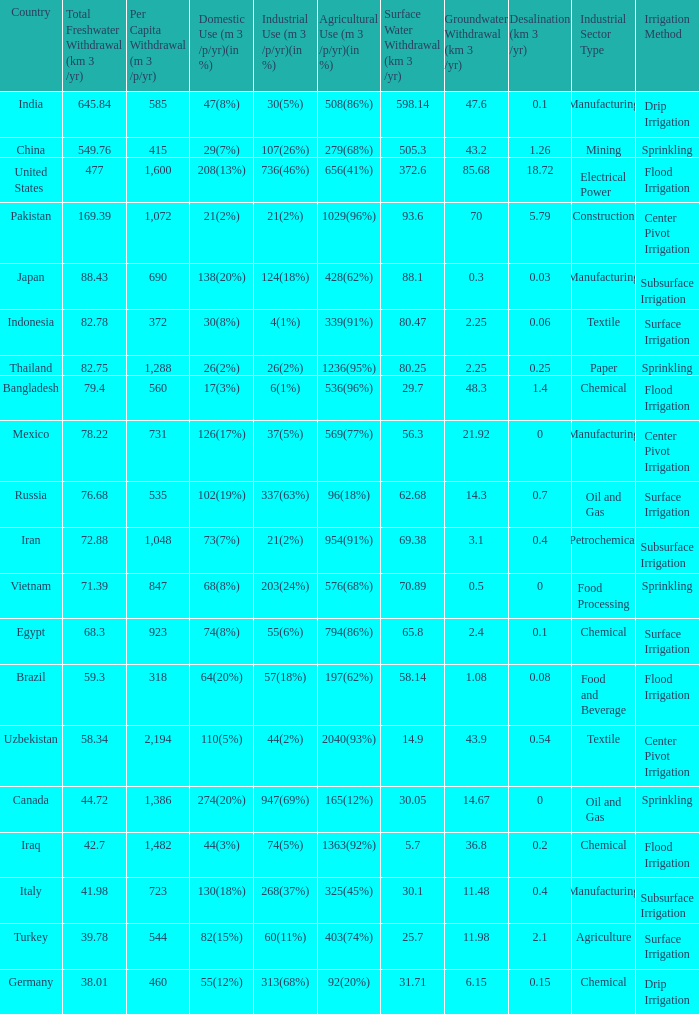What is the highest Per Capita Withdrawal (m 3 /p/yr), when Agricultural Use (m 3 /p/yr)(in %) is 1363(92%), and when Total Freshwater Withdrawal (km 3 /yr) is less than 42.7? None. 